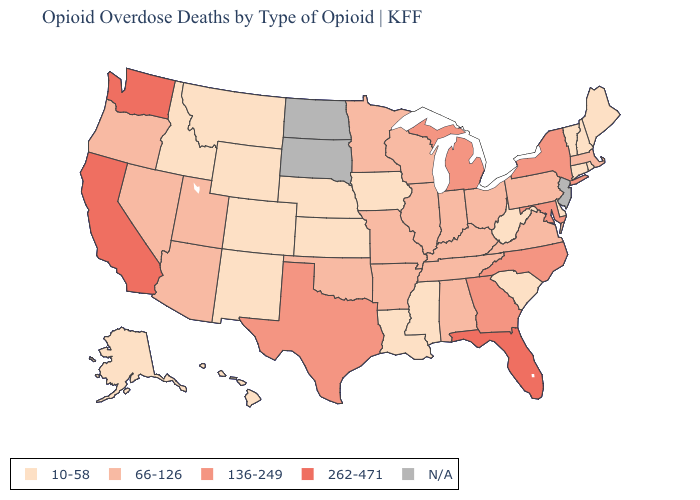What is the highest value in the USA?
Concise answer only. 262-471. What is the lowest value in the USA?
Keep it brief. 10-58. What is the value of Maryland?
Answer briefly. 136-249. What is the lowest value in the Northeast?
Answer briefly. 10-58. What is the highest value in the West ?
Be succinct. 262-471. What is the value of South Dakota?
Keep it brief. N/A. What is the value of Idaho?
Quick response, please. 10-58. What is the value of South Dakota?
Keep it brief. N/A. What is the value of Alabama?
Give a very brief answer. 66-126. Does the map have missing data?
Short answer required. Yes. What is the value of Ohio?
Answer briefly. 66-126. Among the states that border Massachusetts , does Rhode Island have the highest value?
Answer briefly. No. What is the value of California?
Be succinct. 262-471. What is the value of Georgia?
Concise answer only. 136-249. 